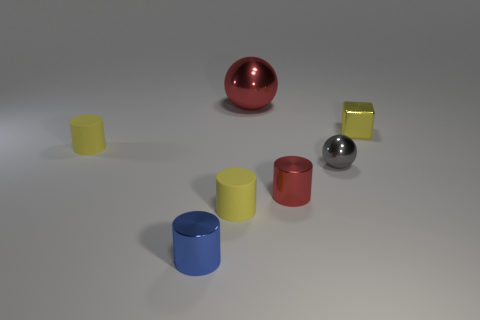Can you describe the colors of the objects? Certainly! In the image, we have objects in a variety of colors. There are two spheres, one is red and the other is silver. Among the cylinders, there is a yellow, a red, and a blue one. Additionally, three cubes are visible: one yellow, one red, and one green. The colors appear solid and uniformly applied to the objects.  Do the colors of the objects hold any symbolic meaning? While the specific intent behind the color choices in this image isn't clear without context, colors often hold symbolic meanings. Red can symbolize passion or danger, blue can represent calmness or stability, yellow might signify happiness or caution, silver could imply modernity or technology, and green may be associated with nature or growth. If this were part of a larger art piece, literature, or cultural setting, the colors might be deliberately chosen to convey specific themes or emotions. 